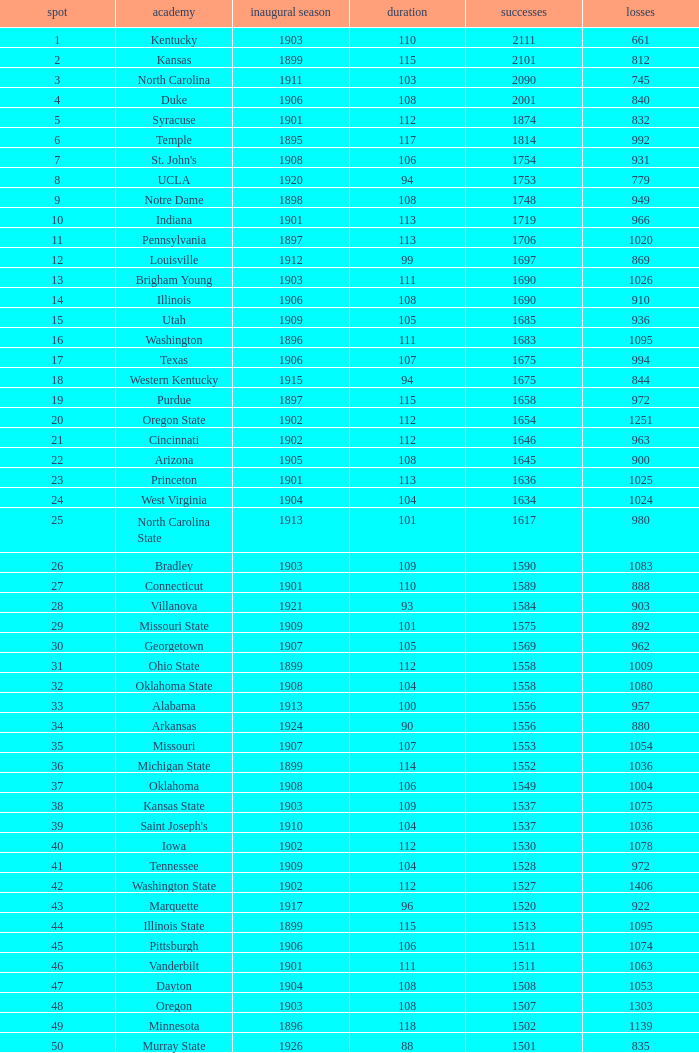How many wins were there for Washington State College with losses greater than 980 and a first season before 1906 and rank greater than 42? 0.0. 